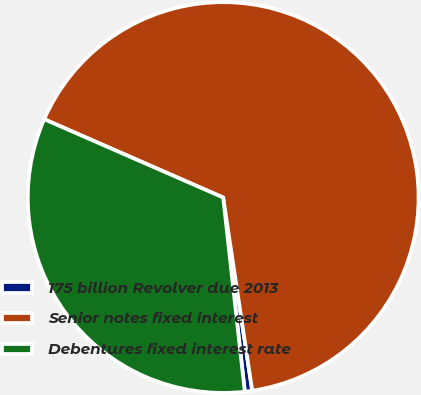Convert chart. <chart><loc_0><loc_0><loc_500><loc_500><pie_chart><fcel>175 billion Revolver due 2013<fcel>Senior notes fixed interest<fcel>Debentures fixed interest rate<nl><fcel>0.61%<fcel>66.06%<fcel>33.33%<nl></chart> 